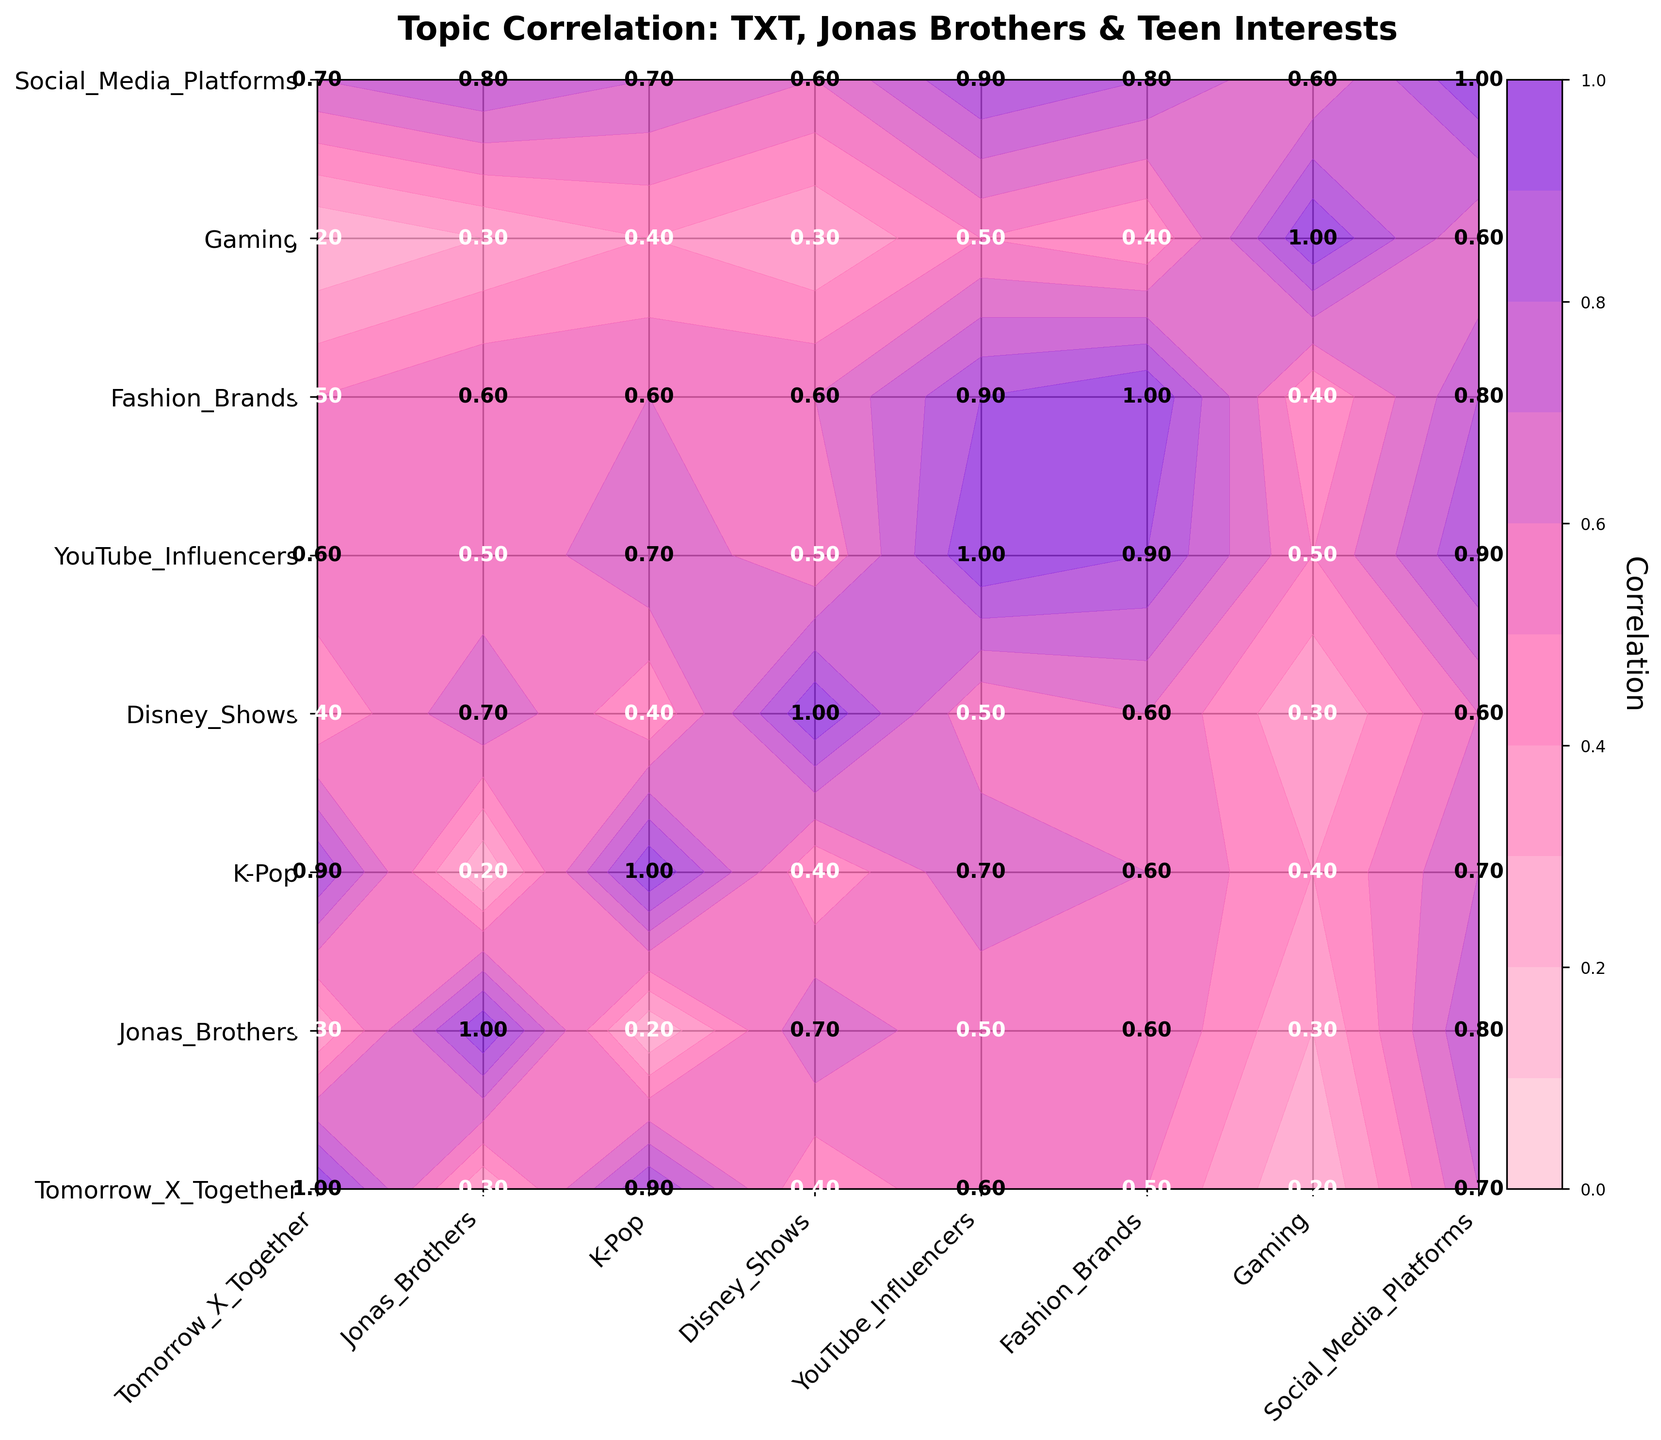What is the title of the plot? The title is displayed at the top center of the plot in bold font. It helps to understand the main idea of the plot.
Answer: "Topic Correlation: TXT, Jonas Brothers & Teen Interests" Which two interests have the highest correlation with Tomorrow X Together? Look at the first row of data values and identify the two highest values after 1.0.
Answer: K-Pop (0.9), Social Media Platforms (0.7) What is the correlation between Jonas Brothers and Disney Shows? Find the intersection of the Jonas Brothers row and Disney Shows column, or vice versa.
Answer: 0.7 Which interest has the lowest correlation with Gaming? Look at the Gaming row and identify the lowest value other than 1.0.
Answer: Tomorrow X Together (0.2) How many interests have a correlation greater than 0.5 with YouTube Influencers? Look through the YouTube Influencers row and count the number of values greater than 0.5.
Answer: 4 (Fashion Brands: 0.9, Social Media Platforms: 0.9, K-Pop: 0.7, Tomorrow X Together: 0.6) What is the most correlated interest pair involving Fashion Brands? Look at the Fashion Brands row and find the highest correlation value and its corresponding interest.
Answer: YouTube Influencers (0.9) Which interest pairs both have a correlation greater than or equal to 0.8? Scan the plot to find pairs with correlation values greater than or equal to 0.8.
Answer: Jonas Brothers and Social Media Platforms (0.8), YouTube Influencers and Social Media Platforms (0.9), Fashion Brands and Social Media Platforms (0.8) Compare the correlation between Tomorrow X Together and K-Pop with that between Jonas Brothers and K-Pop. Which one is higher? Identify the values for each pair and compare them. Tomorrow X Together and K-Pop is 0.9, and Jonas Brothers and K-Pop is 0.2, so the former is higher.
Answer: Tomorrow X Together and K-Pop What are the x-axis and y-axis labels in this plot? The labels along the horizontal and vertical axes represent different interests.
Answer: Interests: ['Tomorrow X Together', 'Jonas Brothers', 'K-Pop', 'Disney Shows', 'YouTube Influencers', 'Fashion Brands', 'Gaming', 'Social Media Platforms'] 